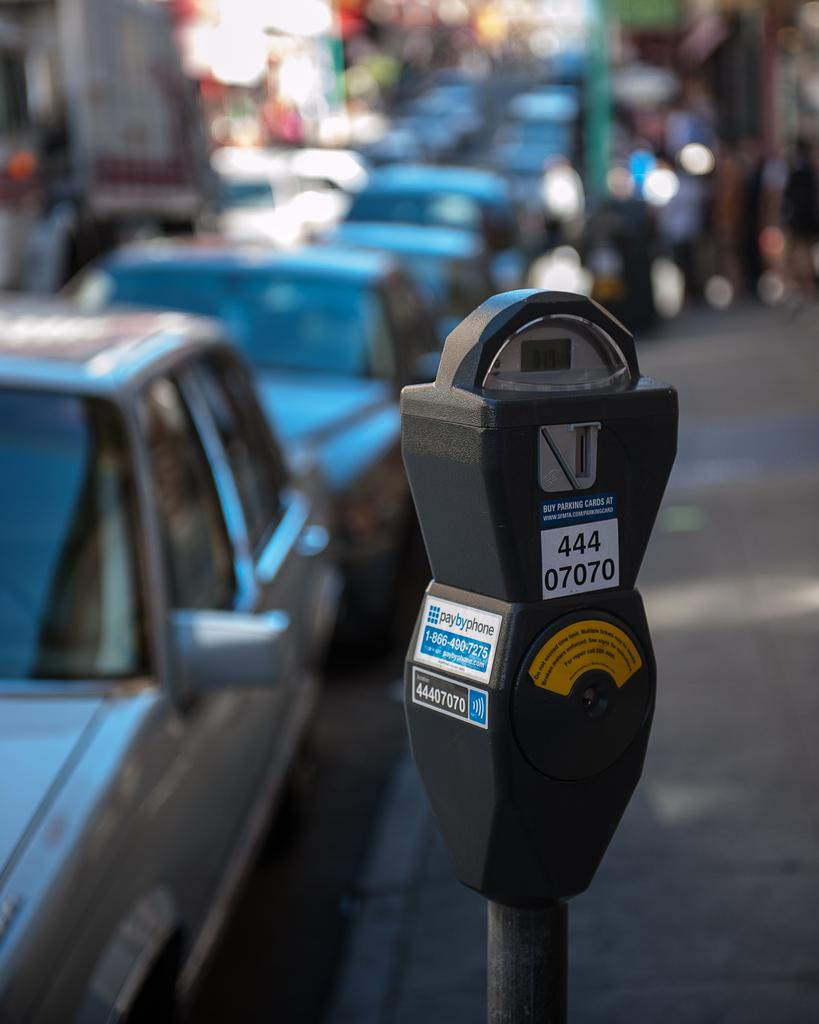Provide a one-sentence caption for the provided image. A parking meter has the numbers 44407070 on the front. 